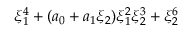<formula> <loc_0><loc_0><loc_500><loc_500>\xi _ { 1 } ^ { 4 } + ( a _ { 0 } + a _ { 1 } \xi _ { 2 } ) \xi _ { 1 } ^ { 2 } \xi _ { 2 } ^ { 3 } + \xi _ { 2 } ^ { 6 }</formula> 